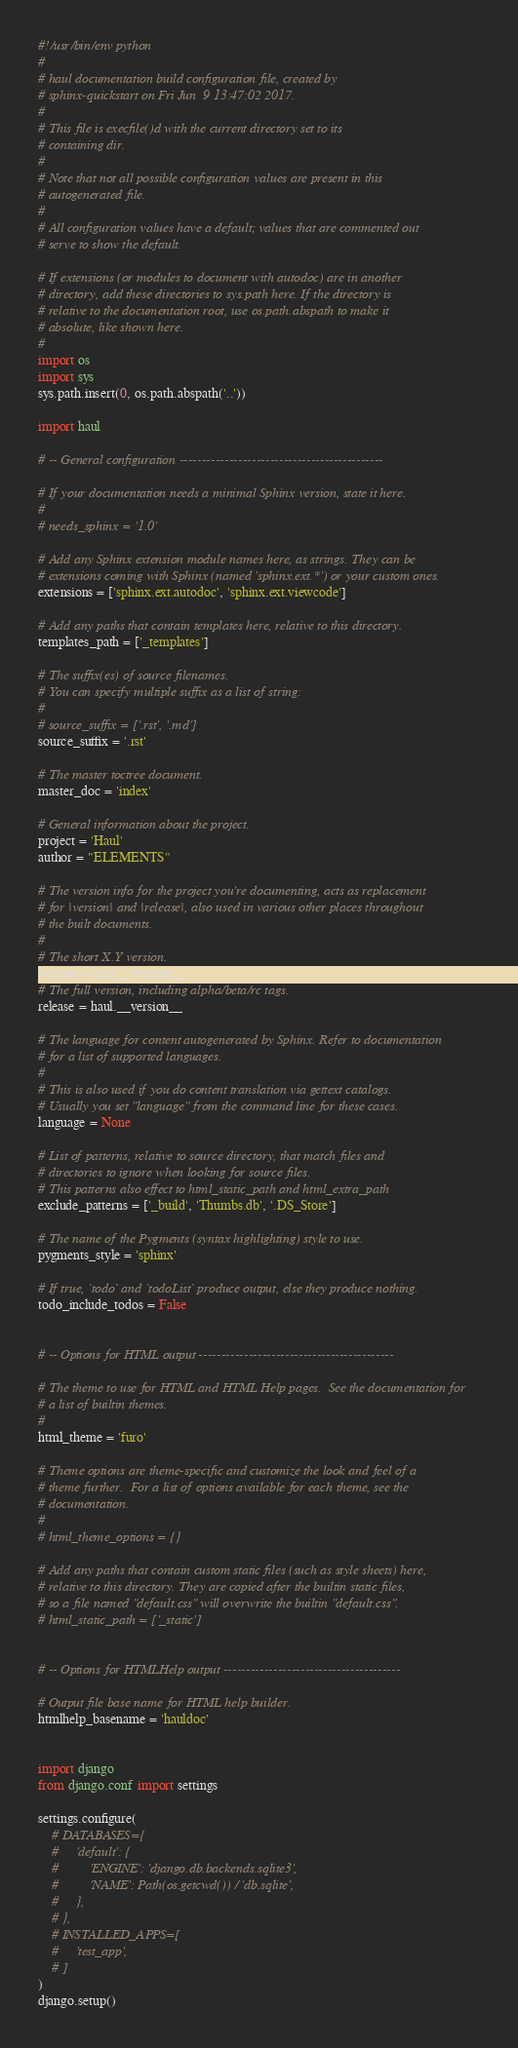Convert code to text. <code><loc_0><loc_0><loc_500><loc_500><_Python_>#!/usr/bin/env python
#
# haul documentation build configuration file, created by
# sphinx-quickstart on Fri Jun  9 13:47:02 2017.
#
# This file is execfile()d with the current directory set to its
# containing dir.
#
# Note that not all possible configuration values are present in this
# autogenerated file.
#
# All configuration values have a default; values that are commented out
# serve to show the default.

# If extensions (or modules to document with autodoc) are in another
# directory, add these directories to sys.path here. If the directory is
# relative to the documentation root, use os.path.abspath to make it
# absolute, like shown here.
#
import os
import sys
sys.path.insert(0, os.path.abspath('..'))

import haul

# -- General configuration ---------------------------------------------

# If your documentation needs a minimal Sphinx version, state it here.
#
# needs_sphinx = '1.0'

# Add any Sphinx extension module names here, as strings. They can be
# extensions coming with Sphinx (named 'sphinx.ext.*') or your custom ones.
extensions = ['sphinx.ext.autodoc', 'sphinx.ext.viewcode']

# Add any paths that contain templates here, relative to this directory.
templates_path = ['_templates']

# The suffix(es) of source filenames.
# You can specify multiple suffix as a list of string:
#
# source_suffix = ['.rst', '.md']
source_suffix = '.rst'

# The master toctree document.
master_doc = 'index'

# General information about the project.
project = 'Haul'
author = "ELEMENTS"

# The version info for the project you're documenting, acts as replacement
# for |version| and |release|, also used in various other places throughout
# the built documents.
#
# The short X.Y version.
version = haul.__version__
# The full version, including alpha/beta/rc tags.
release = haul.__version__

# The language for content autogenerated by Sphinx. Refer to documentation
# for a list of supported languages.
#
# This is also used if you do content translation via gettext catalogs.
# Usually you set "language" from the command line for these cases.
language = None

# List of patterns, relative to source directory, that match files and
# directories to ignore when looking for source files.
# This patterns also effect to html_static_path and html_extra_path
exclude_patterns = ['_build', 'Thumbs.db', '.DS_Store']

# The name of the Pygments (syntax highlighting) style to use.
pygments_style = 'sphinx'

# If true, `todo` and `todoList` produce output, else they produce nothing.
todo_include_todos = False


# -- Options for HTML output -------------------------------------------

# The theme to use for HTML and HTML Help pages.  See the documentation for
# a list of builtin themes.
#
html_theme = 'furo'

# Theme options are theme-specific and customize the look and feel of a
# theme further.  For a list of options available for each theme, see the
# documentation.
#
# html_theme_options = {}

# Add any paths that contain custom static files (such as style sheets) here,
# relative to this directory. They are copied after the builtin static files,
# so a file named "default.css" will overwrite the builtin "default.css".
# html_static_path = ['_static']


# -- Options for HTMLHelp output ---------------------------------------

# Output file base name for HTML help builder.
htmlhelp_basename = 'hauldoc'


import django
from django.conf import settings

settings.configure(
    # DATABASES={
    #     'default': {
    #         'ENGINE': 'django.db.backends.sqlite3',
    #         'NAME': Path(os.getcwd()) / 'db.sqlite',
    #     },
    # },
    # INSTALLED_APPS=[
    #     'test_app',
    # ]
)
django.setup()
</code> 